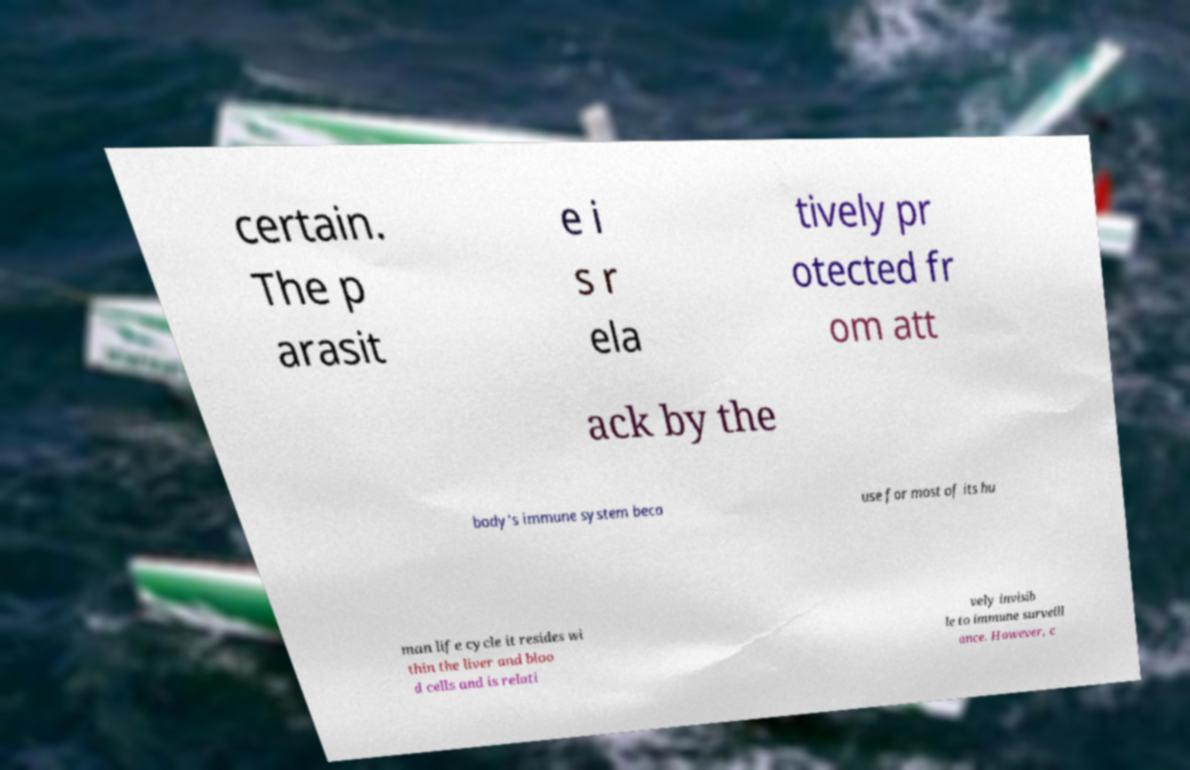Could you extract and type out the text from this image? certain. The p arasit e i s r ela tively pr otected fr om att ack by the body's immune system beca use for most of its hu man life cycle it resides wi thin the liver and bloo d cells and is relati vely invisib le to immune surveill ance. However, c 